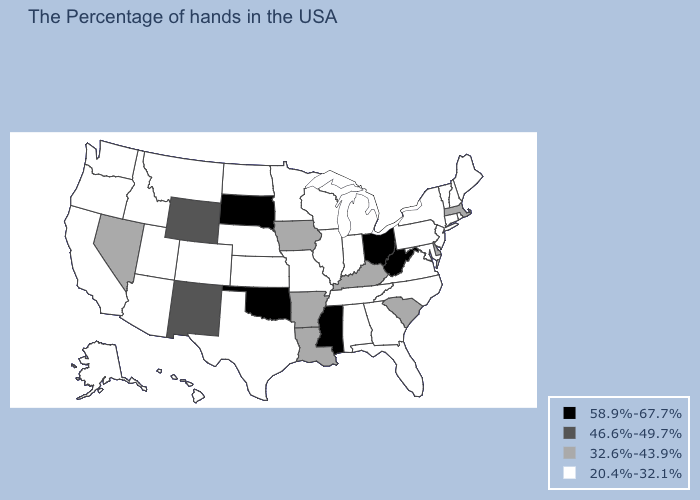What is the value of Ohio?
Concise answer only. 58.9%-67.7%. Among the states that border Kansas , does Oklahoma have the highest value?
Keep it brief. Yes. What is the value of Georgia?
Quick response, please. 20.4%-32.1%. Among the states that border Texas , which have the lowest value?
Answer briefly. Louisiana, Arkansas. Name the states that have a value in the range 20.4%-32.1%?
Short answer required. Maine, Rhode Island, New Hampshire, Vermont, Connecticut, New York, New Jersey, Maryland, Pennsylvania, Virginia, North Carolina, Florida, Georgia, Michigan, Indiana, Alabama, Tennessee, Wisconsin, Illinois, Missouri, Minnesota, Kansas, Nebraska, Texas, North Dakota, Colorado, Utah, Montana, Arizona, Idaho, California, Washington, Oregon, Alaska, Hawaii. What is the value of Tennessee?
Give a very brief answer. 20.4%-32.1%. Name the states that have a value in the range 32.6%-43.9%?
Short answer required. Massachusetts, Delaware, South Carolina, Kentucky, Louisiana, Arkansas, Iowa, Nevada. Which states have the lowest value in the USA?
Write a very short answer. Maine, Rhode Island, New Hampshire, Vermont, Connecticut, New York, New Jersey, Maryland, Pennsylvania, Virginia, North Carolina, Florida, Georgia, Michigan, Indiana, Alabama, Tennessee, Wisconsin, Illinois, Missouri, Minnesota, Kansas, Nebraska, Texas, North Dakota, Colorado, Utah, Montana, Arizona, Idaho, California, Washington, Oregon, Alaska, Hawaii. Name the states that have a value in the range 46.6%-49.7%?
Give a very brief answer. Wyoming, New Mexico. Which states have the lowest value in the South?
Answer briefly. Maryland, Virginia, North Carolina, Florida, Georgia, Alabama, Tennessee, Texas. What is the value of Hawaii?
Short answer required. 20.4%-32.1%. Does Delaware have the lowest value in the USA?
Concise answer only. No. What is the highest value in states that border Indiana?
Concise answer only. 58.9%-67.7%. Name the states that have a value in the range 58.9%-67.7%?
Short answer required. West Virginia, Ohio, Mississippi, Oklahoma, South Dakota. What is the value of Alaska?
Keep it brief. 20.4%-32.1%. 